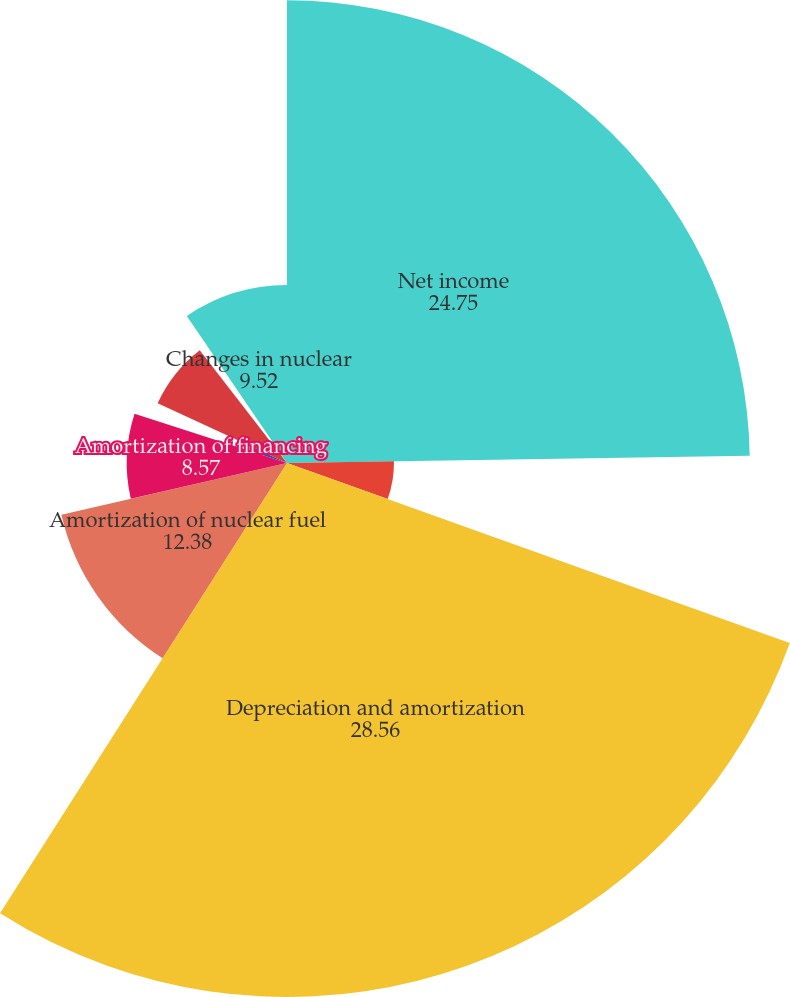Convert chart. <chart><loc_0><loc_0><loc_500><loc_500><pie_chart><fcel>Net income<fcel>Distributions and equity in<fcel>Depreciation and amortization<fcel>Amortization of nuclear fuel<fcel>Amortization of financing<fcel>Amortization of intangibles<fcel>Amortization of unearned<fcel>Loss on disposals and sales of<fcel>Loss/(gain) on sale of<fcel>Changes in nuclear<nl><fcel>24.75%<fcel>5.72%<fcel>28.56%<fcel>12.38%<fcel>8.57%<fcel>1.91%<fcel>7.62%<fcel>0.01%<fcel>0.96%<fcel>9.52%<nl></chart> 